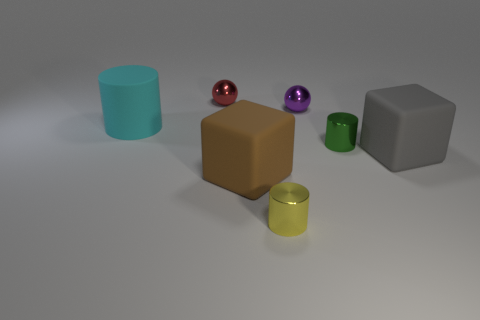Are there any big objects that have the same color as the matte cylinder?
Keep it short and to the point. No. There is another matte block that is the same size as the brown rubber cube; what is its color?
Offer a terse response. Gray. There is a big rubber cylinder; is it the same color as the metallic ball that is in front of the tiny red thing?
Keep it short and to the point. No. What color is the large cylinder?
Your answer should be compact. Cyan. There is a sphere that is left of the tiny yellow shiny cylinder; what is its material?
Ensure brevity in your answer.  Metal. There is another thing that is the same shape as the small purple shiny thing; what is its size?
Your response must be concise. Small. Are there fewer red shiny balls in front of the big gray object than metallic balls?
Keep it short and to the point. Yes. Are any large brown rubber blocks visible?
Ensure brevity in your answer.  Yes. There is another small thing that is the same shape as the green thing; what color is it?
Offer a very short reply. Yellow. Do the small sphere to the left of the brown rubber block and the rubber cylinder have the same color?
Your response must be concise. No. 